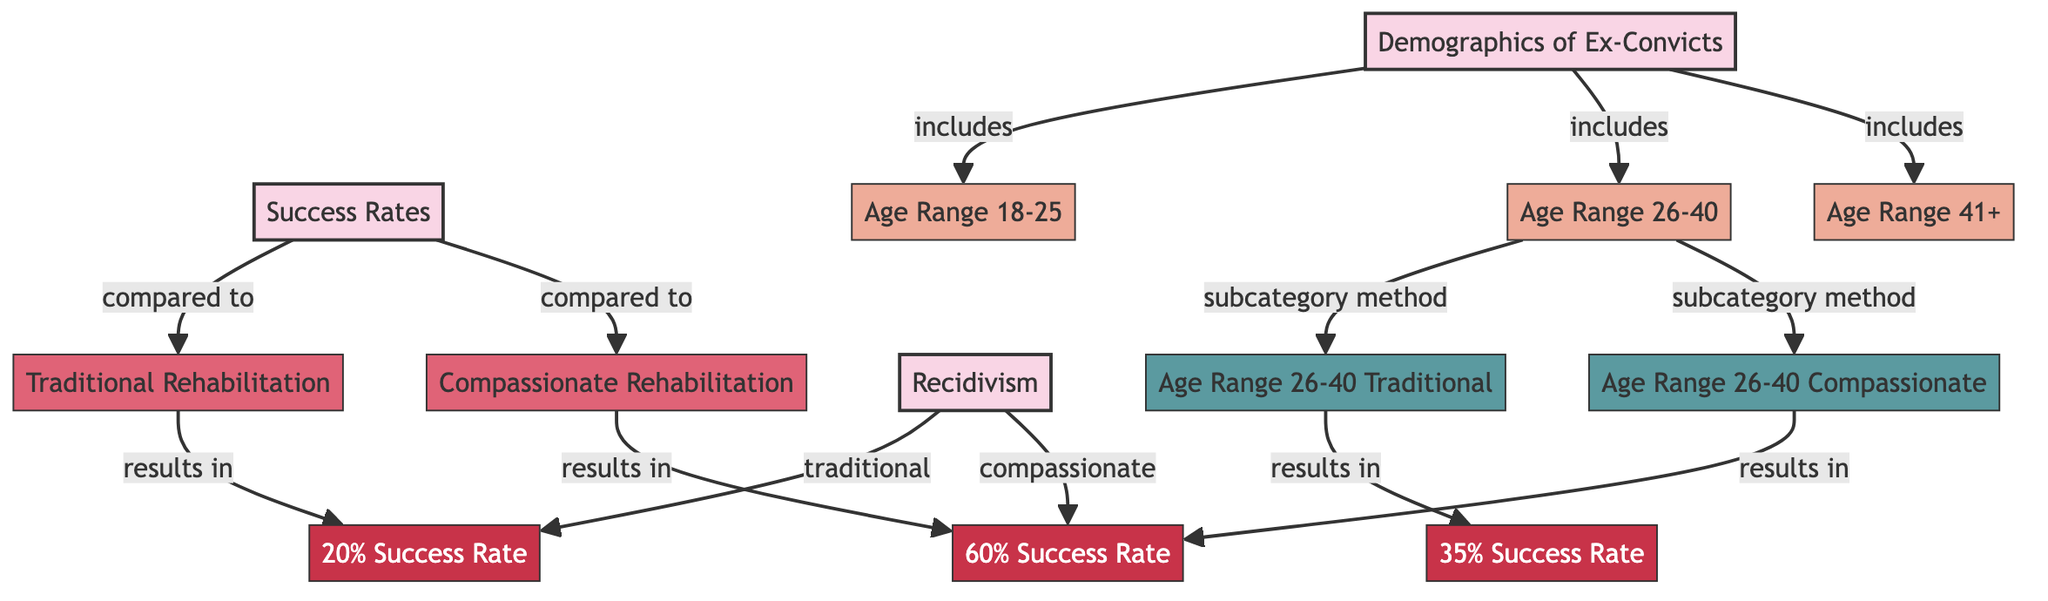What is the success rate of traditional rehabilitation? The diagram indicates that traditional rehabilitation results in a 20% success rate, as shown by the corresponding metric node linked to traditional rehabilitation.
Answer: 20% success rate What age range is included in the demographics of ex-convicts? The diagram specifies three age ranges: 18-25, 26-40, and 41+, which are listed under the demographics node, showing the components included in this category.
Answer: 18-25, 26-40, 41+ What is the success rate of compassionate rehabilitation for age range 41+? From the diagram, it shows that compassionate rehabilitation results in a 60% success rate for the age range 41 and above, directly linked to the compassionate method metric node.
Answer: 60% success rate Which rehabilitation method has a higher success rate for age range 26-40? The diagram shows that compassionate rehabilitation has a success rate of 35% while traditional rehabilitation has a success rate of 20%. Therefore, compassionate rehabilitation has a higher success rate for this age range.
Answer: Compassionate rehabilitation How many subcategories of age ranges are included in the diagram? The diagram includes three subcategories of age ranges: 18-25, 26-40, and 41+, which can be counted as separate entities under the demographics node.
Answer: 3 